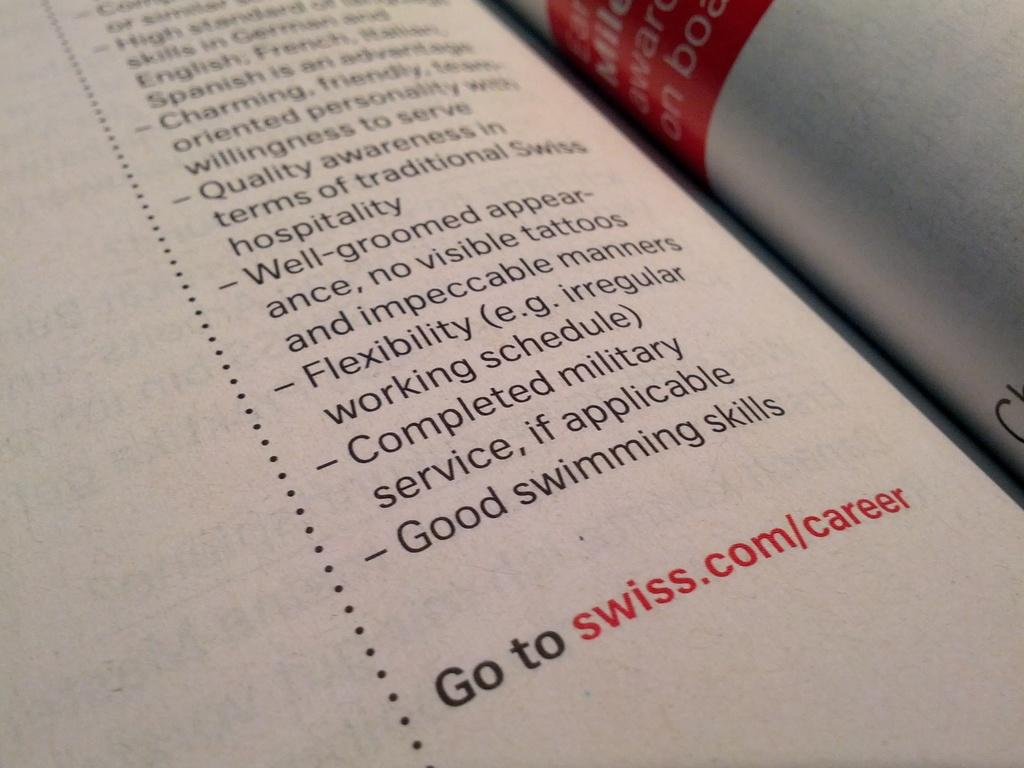Provide a one-sentence caption for the provided image. A point form list about what is required to work at Swiss and you can find more at swiss.com/career. 